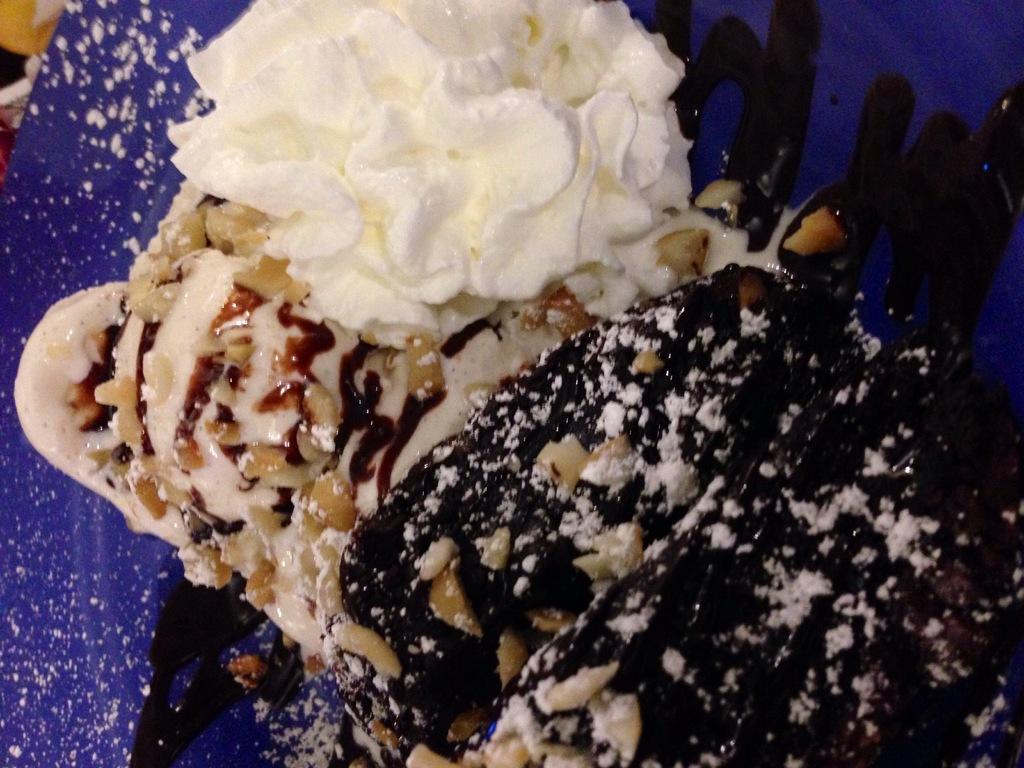Can you describe this image briefly? In this picture we can see a food item with creams and nuts on it and in the background we can see a violet color object. 